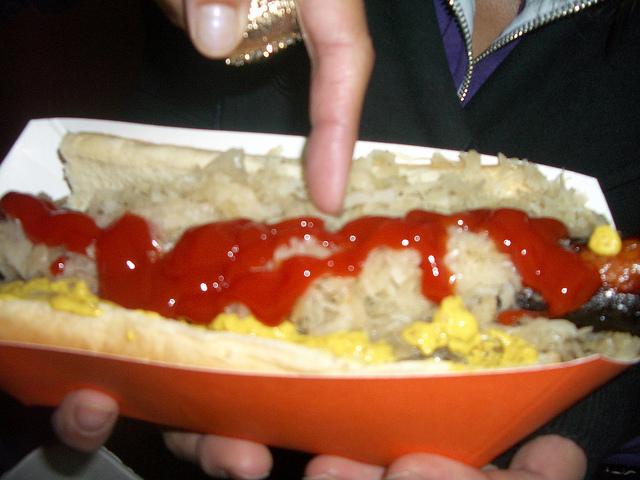What is this person holding?
Quick response, please. Hot dog. Is the person wearing nail polish?
Give a very brief answer. No. Where is the food?
Quick response, please. In dish. How many of the person's fingers are visible?
Concise answer only. 7. 